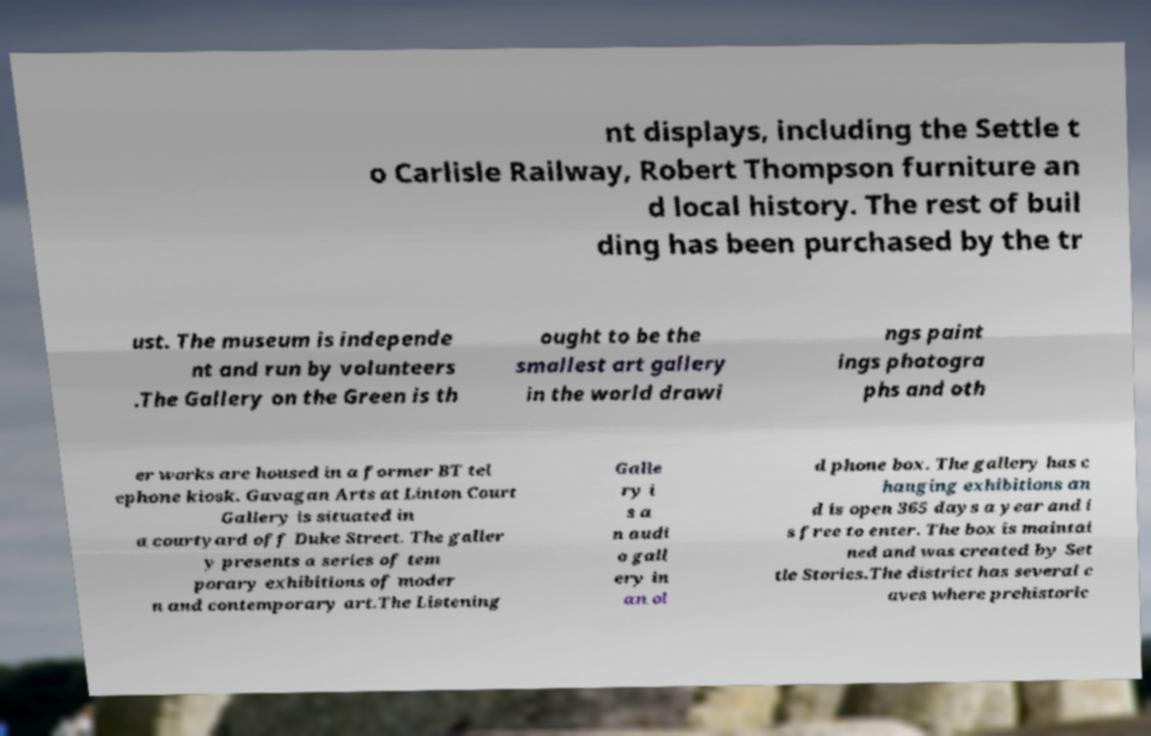Could you assist in decoding the text presented in this image and type it out clearly? nt displays, including the Settle t o Carlisle Railway, Robert Thompson furniture an d local history. The rest of buil ding has been purchased by the tr ust. The museum is independe nt and run by volunteers .The Gallery on the Green is th ought to be the smallest art gallery in the world drawi ngs paint ings photogra phs and oth er works are housed in a former BT tel ephone kiosk. Gavagan Arts at Linton Court Gallery is situated in a courtyard off Duke Street. The galler y presents a series of tem porary exhibitions of moder n and contemporary art.The Listening Galle ry i s a n audi o gall ery in an ol d phone box. The gallery has c hanging exhibitions an d is open 365 days a year and i s free to enter. The box is maintai ned and was created by Set tle Stories.The district has several c aves where prehistoric 